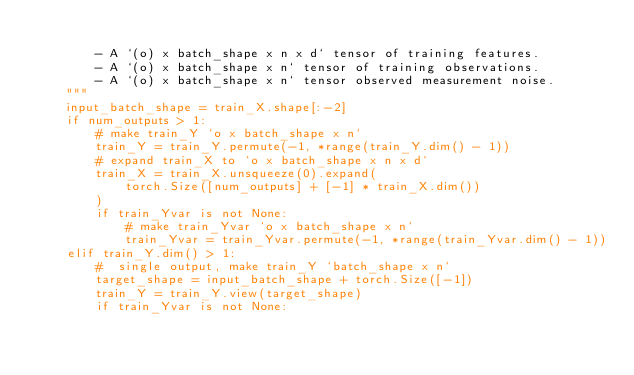<code> <loc_0><loc_0><loc_500><loc_500><_Python_>
        - A `(o) x batch_shape x n x d` tensor of training features.
        - A `(o) x batch_shape x n` tensor of training observations.
        - A `(o) x batch_shape x n` tensor observed measurement noise.
    """
    input_batch_shape = train_X.shape[:-2]
    if num_outputs > 1:
        # make train_Y `o x batch_shape x n`
        train_Y = train_Y.permute(-1, *range(train_Y.dim() - 1))
        # expand train_X to `o x batch_shape x n x d`
        train_X = train_X.unsqueeze(0).expand(
            torch.Size([num_outputs] + [-1] * train_X.dim())
        )
        if train_Yvar is not None:
            # make train_Yvar `o x batch_shape x n`
            train_Yvar = train_Yvar.permute(-1, *range(train_Yvar.dim() - 1))
    elif train_Y.dim() > 1:
        #  single output, make train_Y `batch_shape x n`
        target_shape = input_batch_shape + torch.Size([-1])
        train_Y = train_Y.view(target_shape)
        if train_Yvar is not None:</code> 